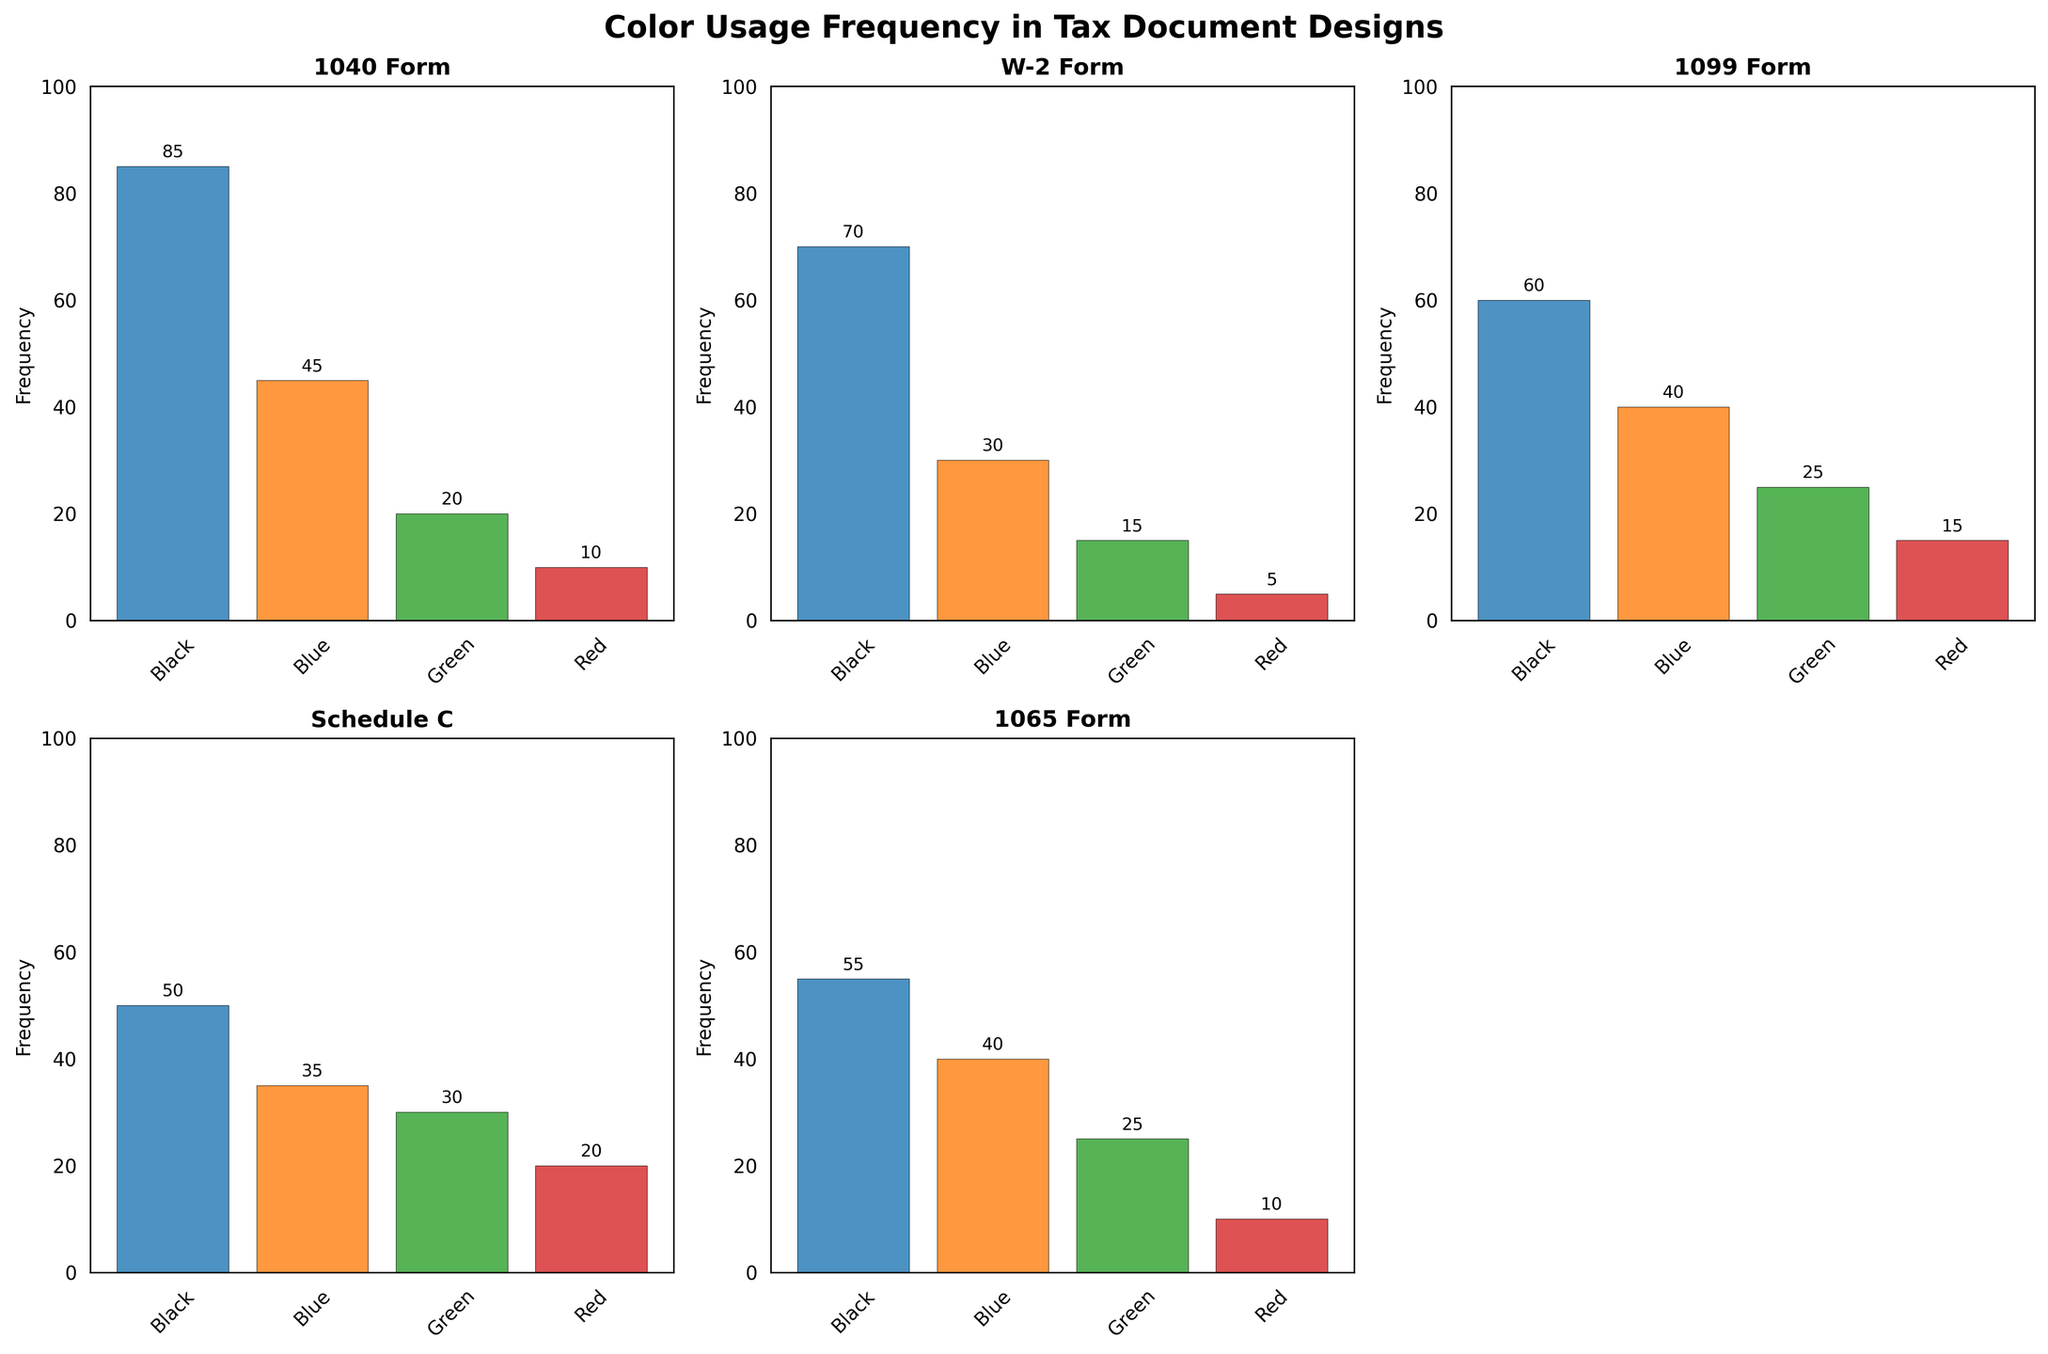What is the title of the figure? The title is located at the top of the figure in bold font. It reads "Color Usage Frequency in Tax Document Designs".
Answer: Color Usage Frequency in Tax Document Designs Which document type uses black most frequently? By examining the black bars in each subplot, we notice that the 1040 Form has the tallest black bar, indicating the highest frequency of black usage.
Answer: 1040 Form What is the least used color in the W-2 Form? In the W-2 Form subplot, the shortest bar corresponds to the color Red.
Answer: Red How many document types are shown in the figure? The figure contains subplots for five document types: 1040 Form, W-2 Form, 1099 Form, Schedule C, and 1065 Form.
Answer: 5 Which document type has the widest range of color frequency? To determine this, we need to look at the difference in frequency between the most and least used colors for each document type. The Schedule C shows a wide range from 50 (Black) to 20 (Red), which is not the highest. The 1040 Form ranges from 85 (Black) to 10 (Red), showing the widest frequency range of 75.
Answer: 1040 Form What is the sum of the frequencies of blue and green in the 1099 Form? In the 1099 Form subplot, the frequency of Blue is 40 and Green is 25. The sum of these two values is 40 + 25.
Answer: 65 Compare the frequency of green usage between the Schedule C and 1065 Form; which one is higher? In the Schedule C subplot, the Green bar shows a frequency of 30, while in the 1065 Form subplot, the Green bar shows a frequency of 25. Therefore, the frequency of Green is higher in the Schedule C.
Answer: Schedule C What is the average frequency of color usage in the 1065 Form? To find the average frequency, sum up the frequencies of all colors in 1065 Form and divide by the number of colors. The sum is 55 (Black) + 40 (Blue) + 25 (Green) + 10 (Red) = 130. The average is 130 / 4.
Answer: 32.5 Across all document types, which color appears to be used the least based on the subplots? By scanning all subplots, we see that, in general, Red has the shortest bars across most document types.
Answer: Red Is the color usage more evenly distributed in the Schedule C compared to other document types? The Schedule C subplot shows frequencies of 50 (Black), 35(Blue), 30(Green), and 20 (Red), which indicate a more balanced and close frequency distribution compared to other document types like the 1040 Form where the frequency varies more drastically.
Answer: Yes 